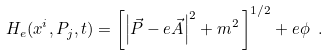<formula> <loc_0><loc_0><loc_500><loc_500>H _ { e } ( x ^ { i } , P _ { j } , t ) = \left [ \left | \vec { P } - e \vec { A } \right | ^ { 2 } + m ^ { 2 } \, \right ] ^ { 1 / 2 } + e \phi \ .</formula> 